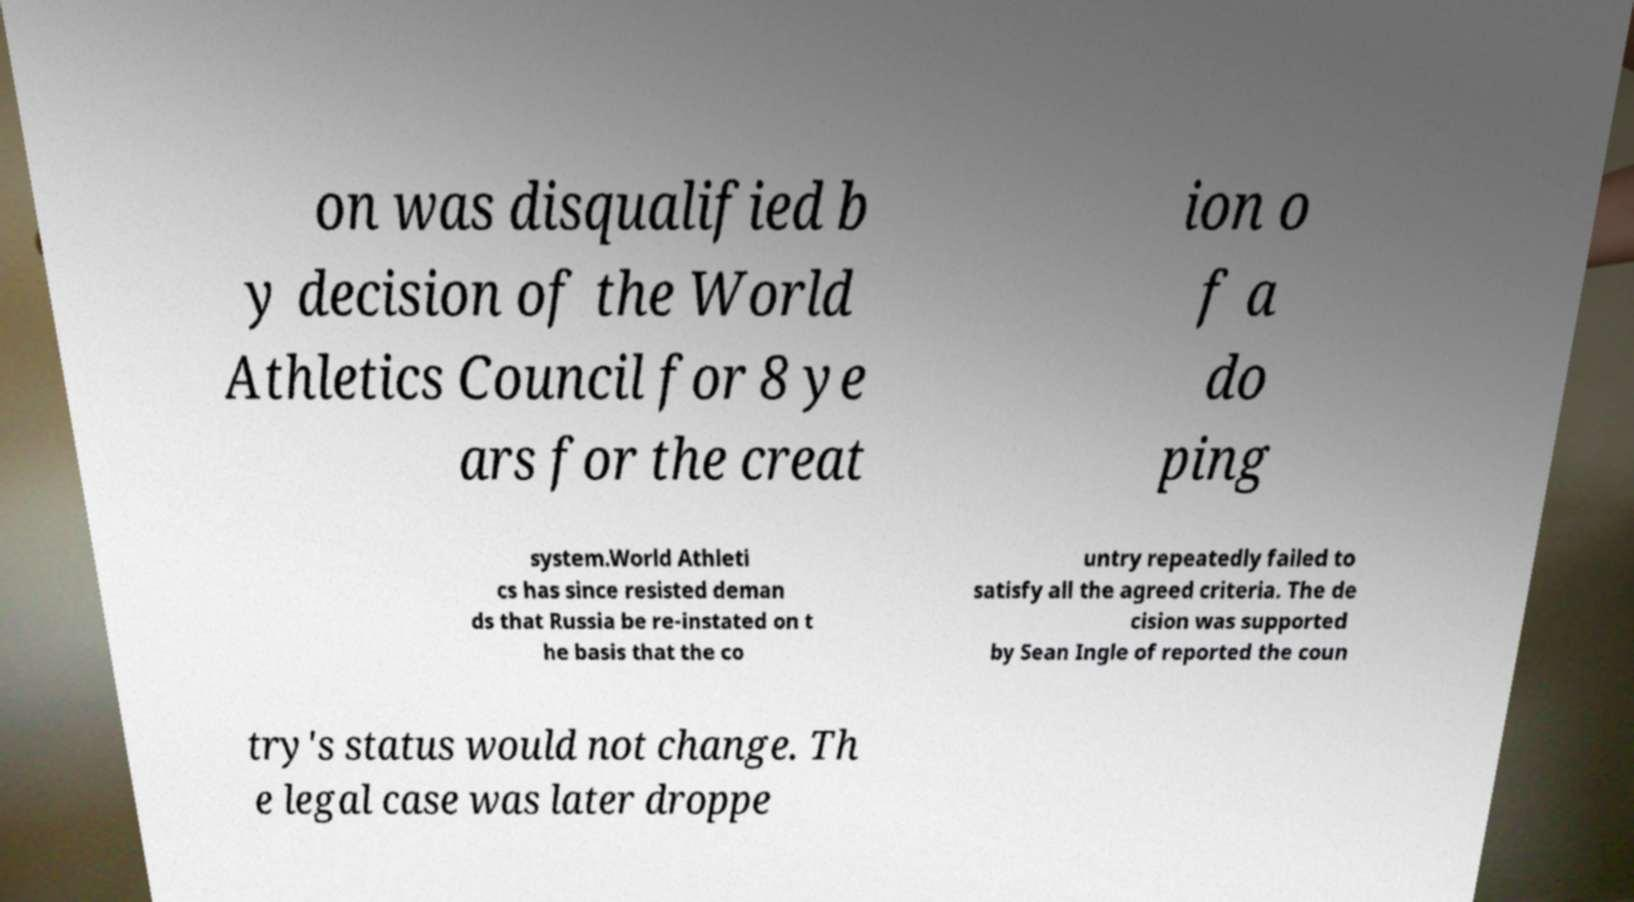Can you read and provide the text displayed in the image?This photo seems to have some interesting text. Can you extract and type it out for me? on was disqualified b y decision of the World Athletics Council for 8 ye ars for the creat ion o f a do ping system.World Athleti cs has since resisted deman ds that Russia be re-instated on t he basis that the co untry repeatedly failed to satisfy all the agreed criteria. The de cision was supported by Sean Ingle of reported the coun try's status would not change. Th e legal case was later droppe 